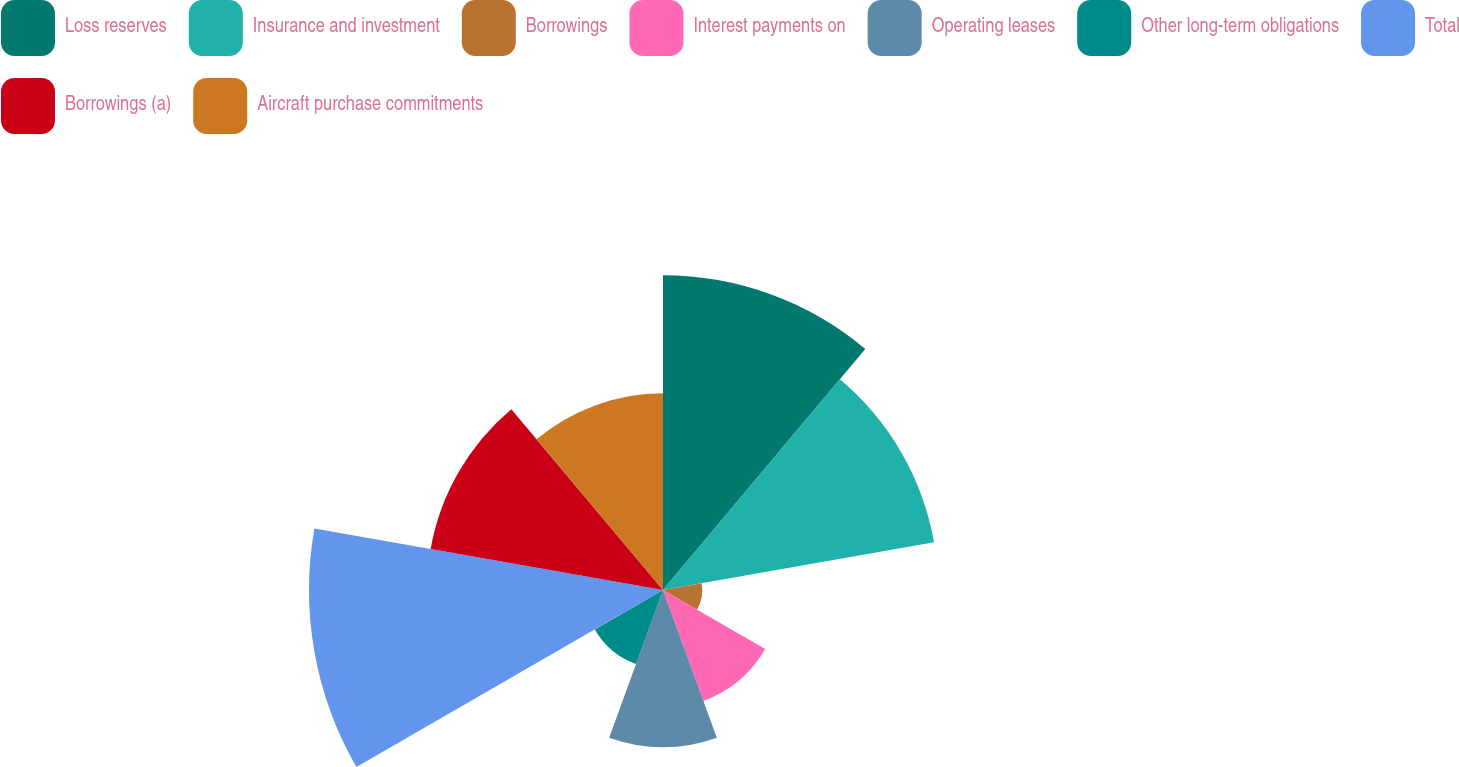Convert chart to OTSL. <chart><loc_0><loc_0><loc_500><loc_500><pie_chart><fcel>Loss reserves<fcel>Insurance and investment<fcel>Borrowings<fcel>Interest payments on<fcel>Operating leases<fcel>Other long-term obligations<fcel>Total<fcel>Borrowings (a)<fcel>Aircraft purchase commitments<nl><fcel>17.78%<fcel>15.55%<fcel>2.22%<fcel>6.67%<fcel>8.89%<fcel>4.45%<fcel>20.0%<fcel>13.33%<fcel>11.11%<nl></chart> 